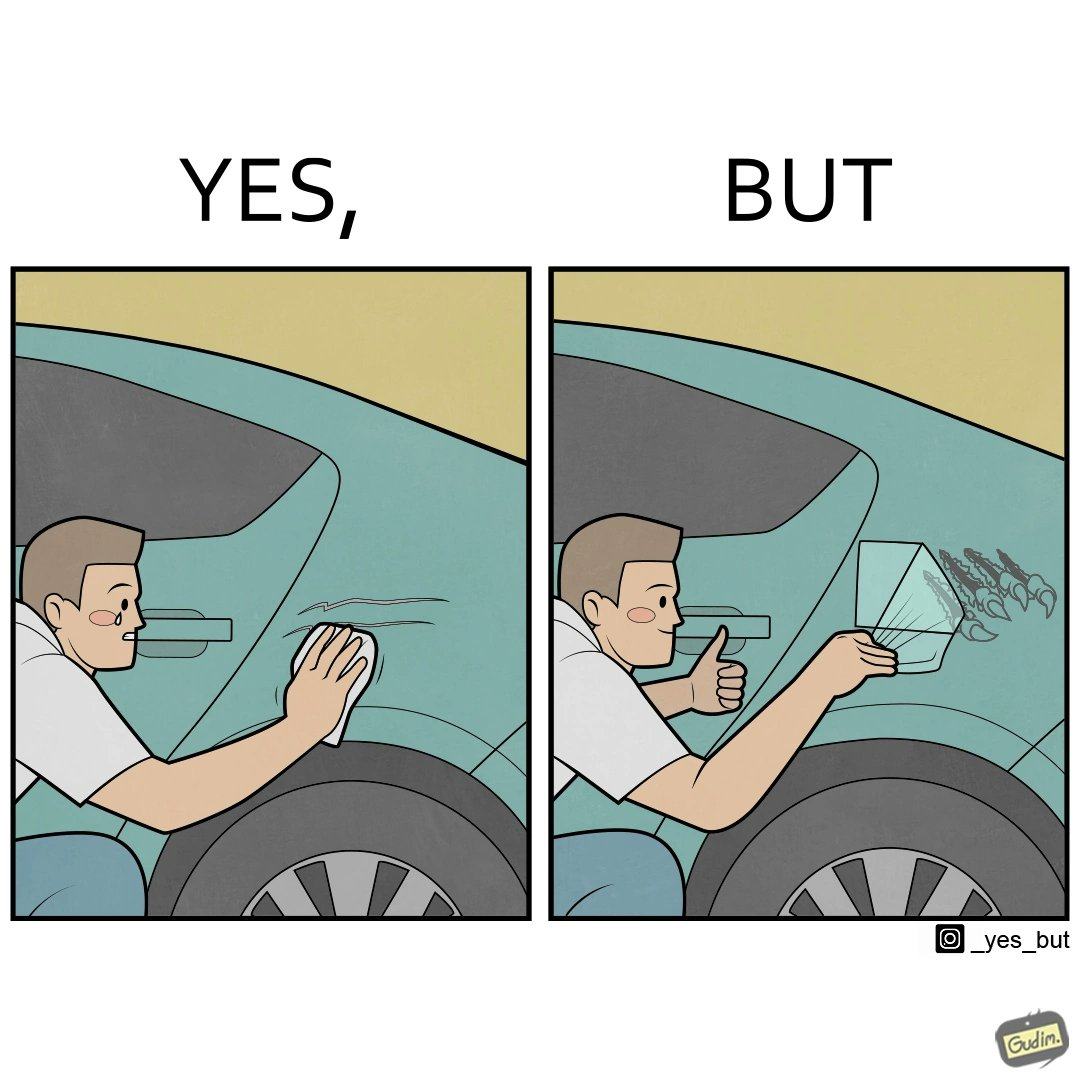What is shown in the left half versus the right half of this image? In the left part of the image: a person is trying to remove the scratches on his car while crying on them In the right part of the image: a person happily applies car decal or some logo on his car to make it look stylish 